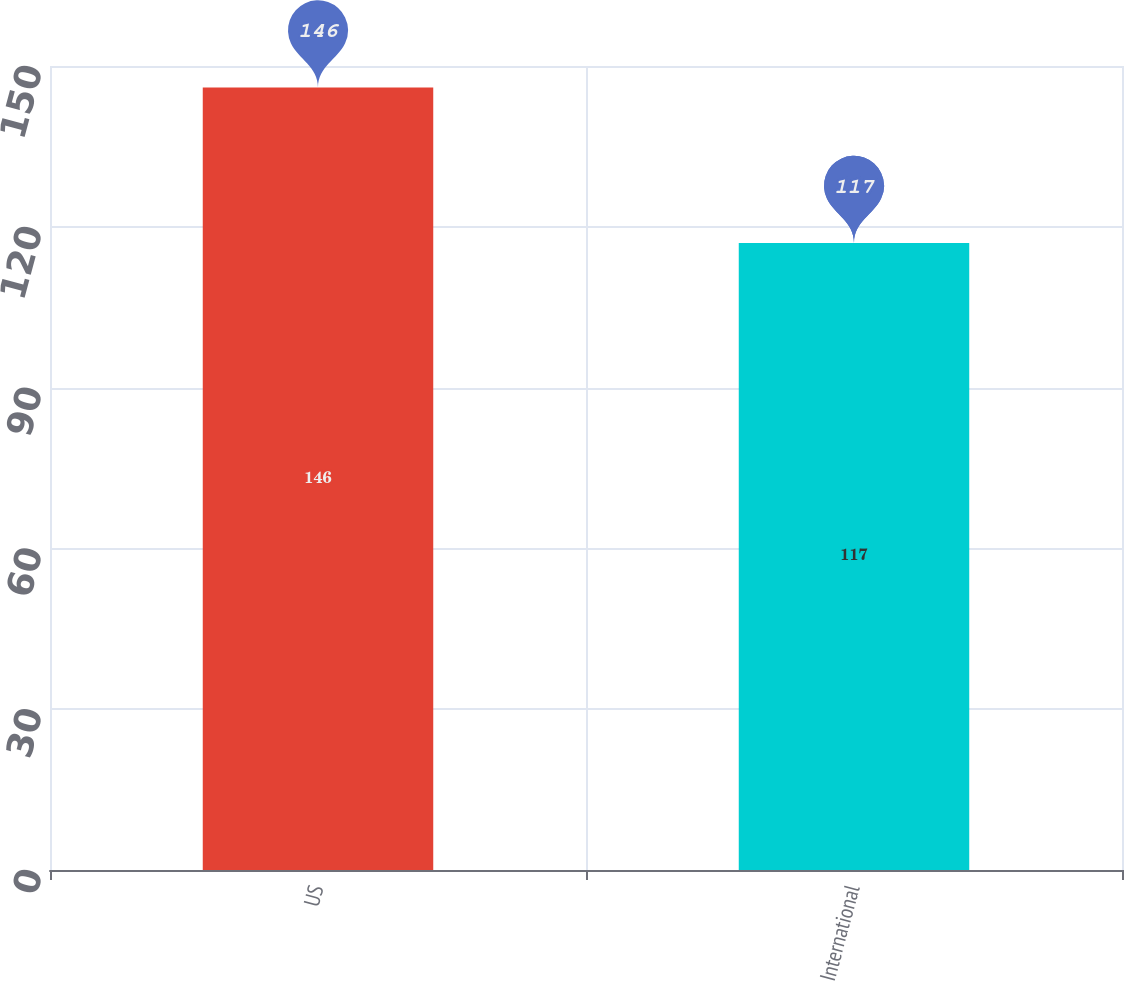<chart> <loc_0><loc_0><loc_500><loc_500><bar_chart><fcel>US<fcel>International<nl><fcel>146<fcel>117<nl></chart> 